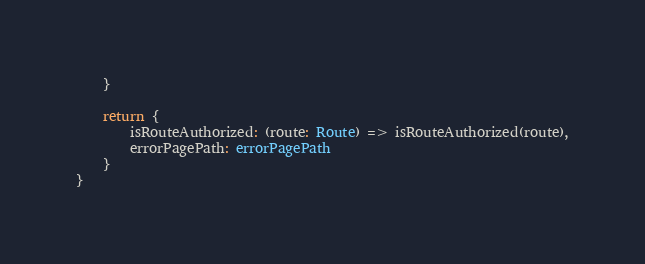Convert code to text. <code><loc_0><loc_0><loc_500><loc_500><_TypeScript_>    }

    return {
        isRouteAuthorized: (route: Route) => isRouteAuthorized(route),
        errorPagePath: errorPagePath
    }
}</code> 